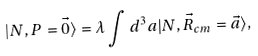<formula> <loc_0><loc_0><loc_500><loc_500>| N , P = \vec { 0 } \rangle = \lambda \int d ^ { 3 } a | N , \vec { R } _ { c m } = \vec { a } \rangle ,</formula> 